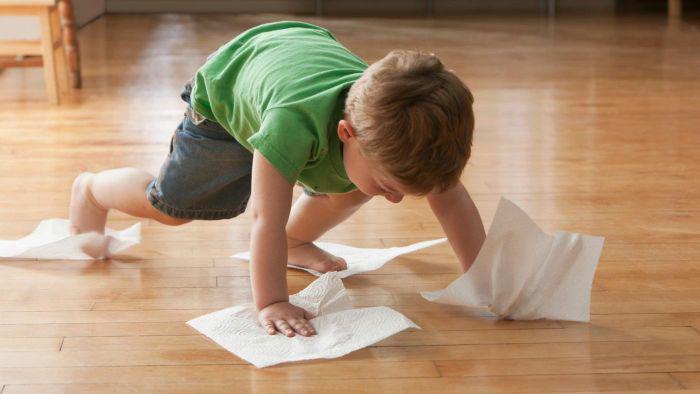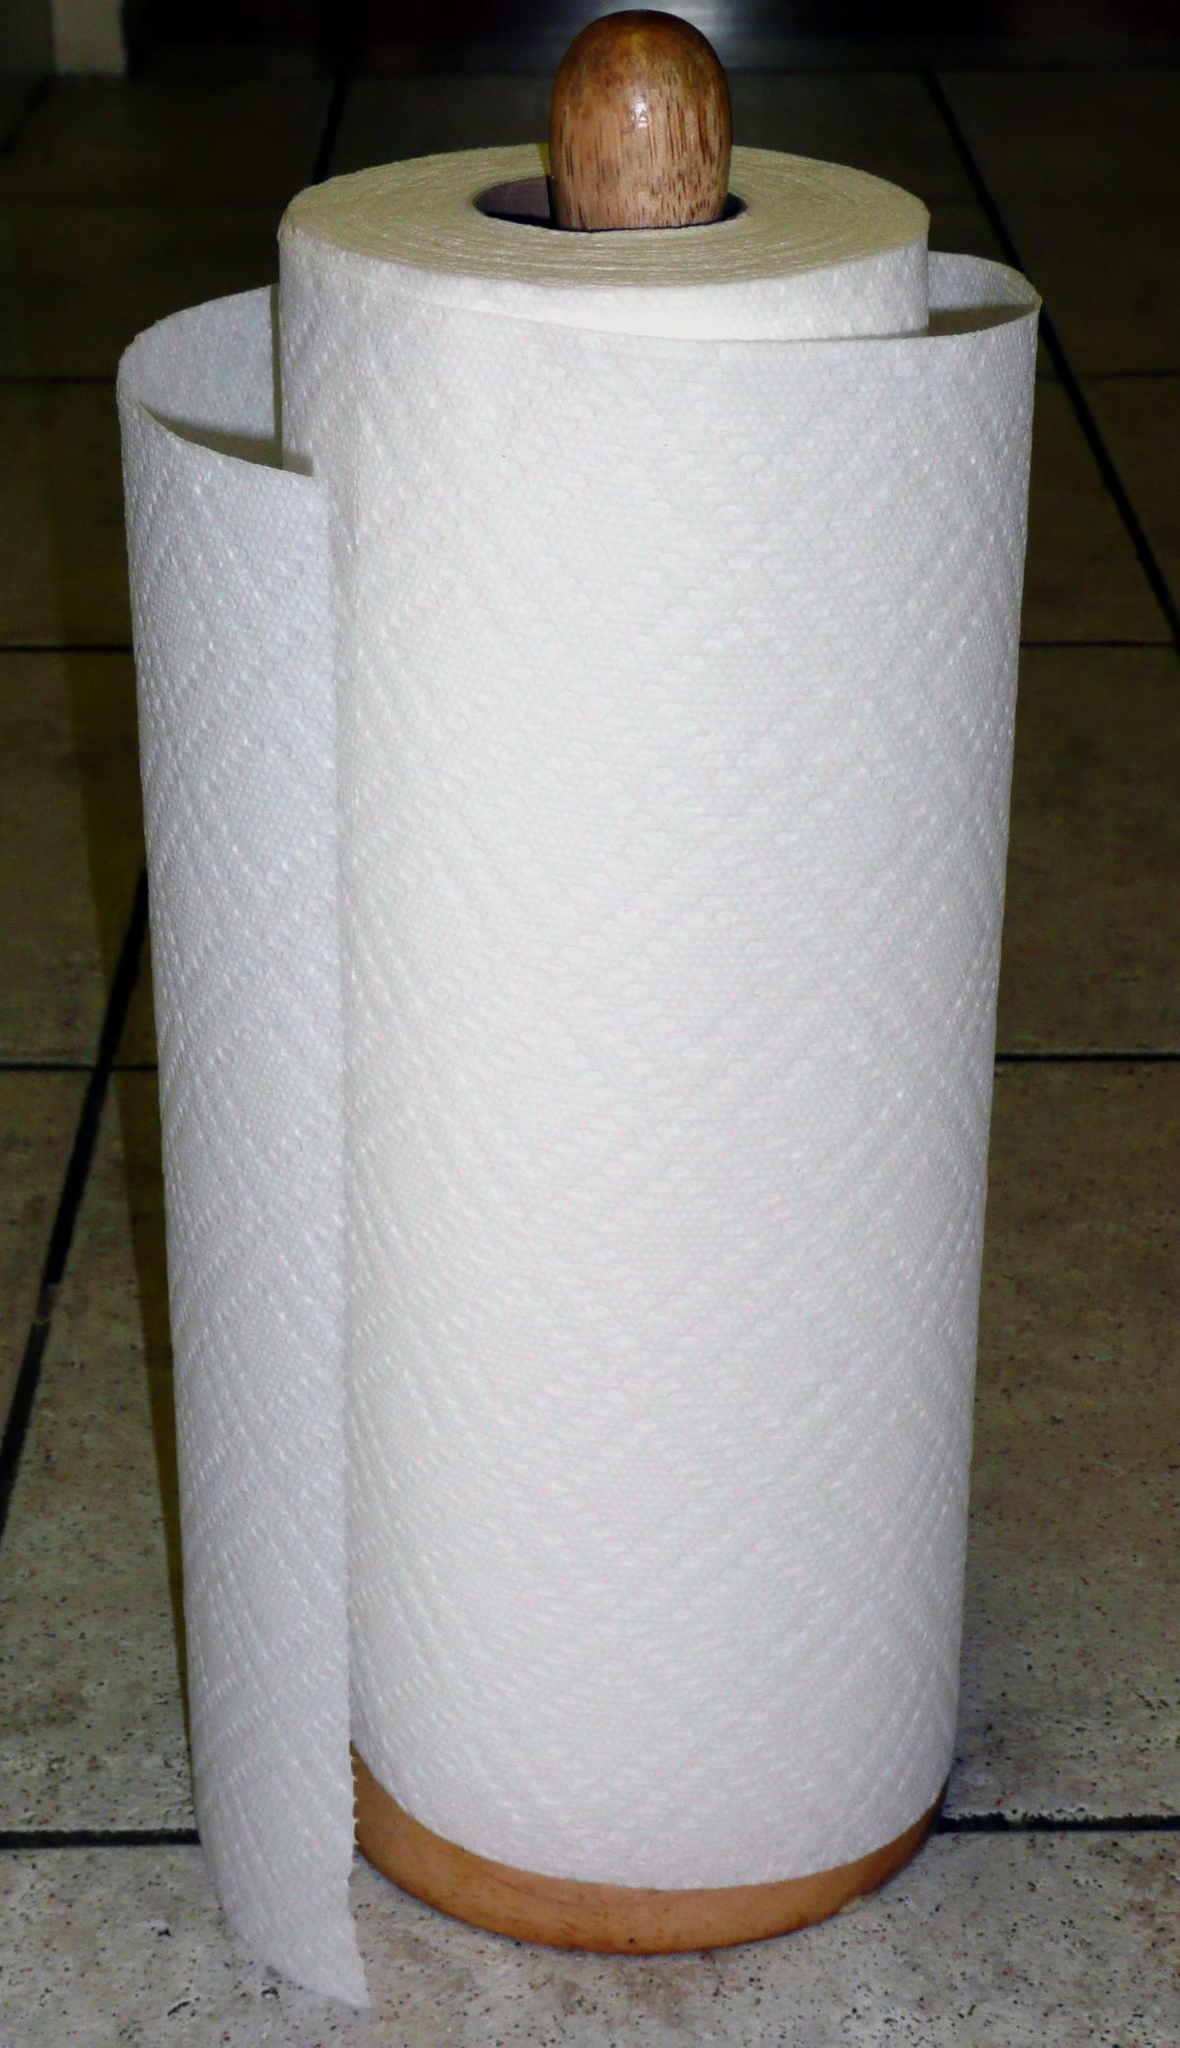The first image is the image on the left, the second image is the image on the right. Analyze the images presented: Is the assertion "An image shows a single white roll on a wood surface." valid? Answer yes or no. No. 